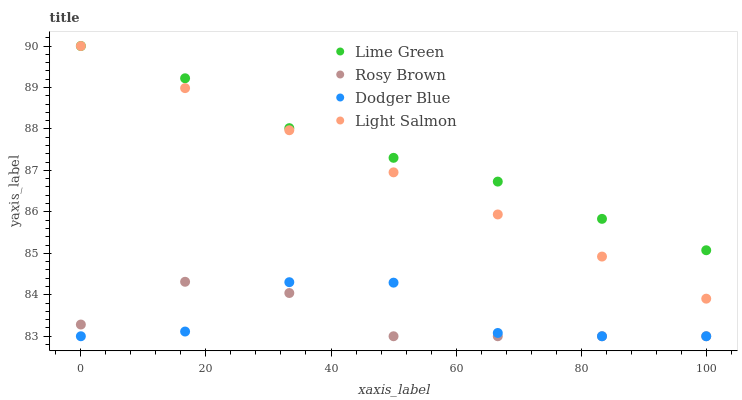Does Rosy Brown have the minimum area under the curve?
Answer yes or no. Yes. Does Lime Green have the maximum area under the curve?
Answer yes or no. Yes. Does Light Salmon have the minimum area under the curve?
Answer yes or no. No. Does Light Salmon have the maximum area under the curve?
Answer yes or no. No. Is Light Salmon the smoothest?
Answer yes or no. Yes. Is Dodger Blue the roughest?
Answer yes or no. Yes. Is Rosy Brown the smoothest?
Answer yes or no. No. Is Rosy Brown the roughest?
Answer yes or no. No. Does Dodger Blue have the lowest value?
Answer yes or no. Yes. Does Light Salmon have the lowest value?
Answer yes or no. No. Does Lime Green have the highest value?
Answer yes or no. Yes. Does Rosy Brown have the highest value?
Answer yes or no. No. Is Rosy Brown less than Light Salmon?
Answer yes or no. Yes. Is Lime Green greater than Dodger Blue?
Answer yes or no. Yes. Does Light Salmon intersect Lime Green?
Answer yes or no. Yes. Is Light Salmon less than Lime Green?
Answer yes or no. No. Is Light Salmon greater than Lime Green?
Answer yes or no. No. Does Rosy Brown intersect Light Salmon?
Answer yes or no. No. 